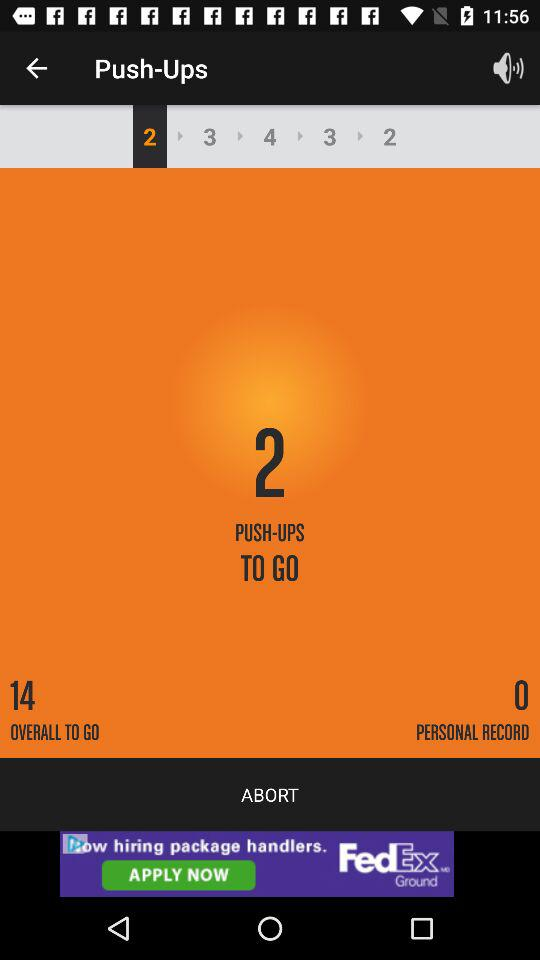What is the personal record? The personal record is 0. 